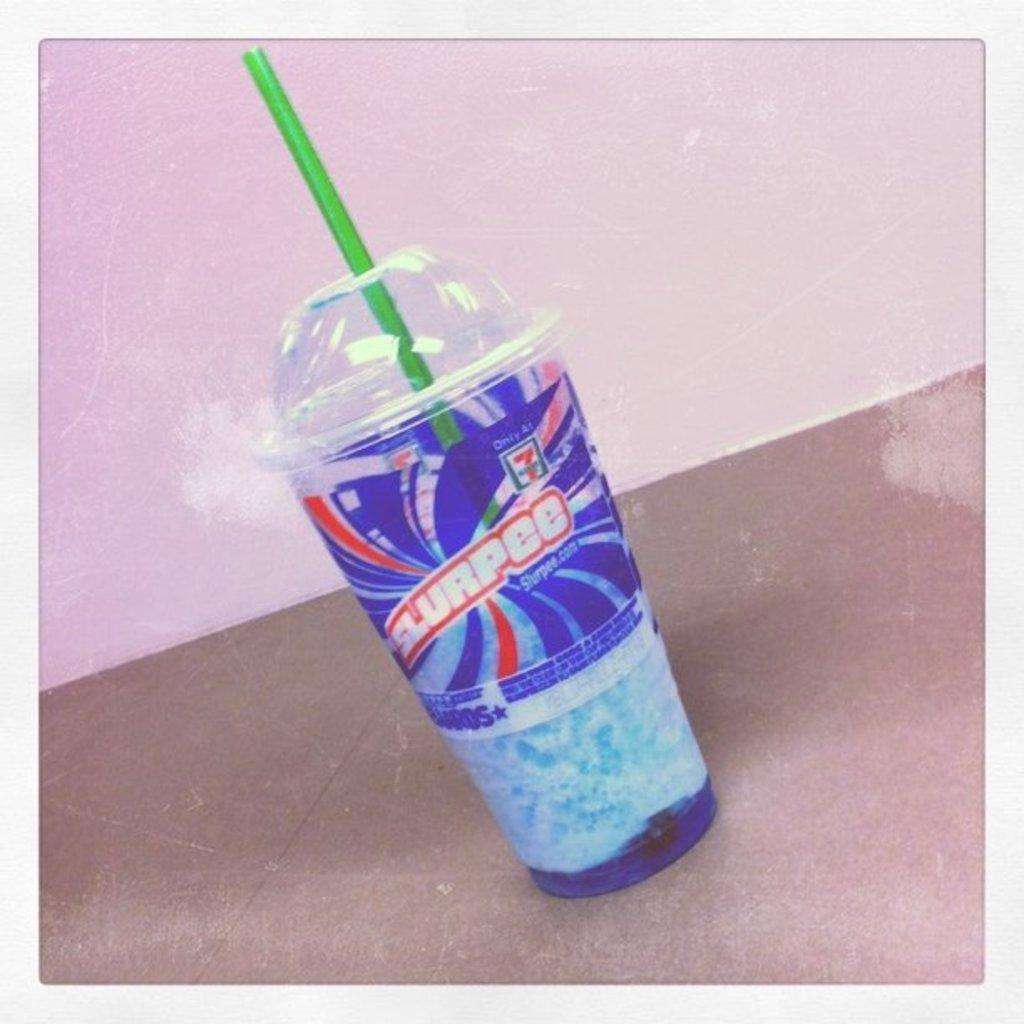What is present in the image? There is a cup in the image. What color is the cup? The cup is blue. What is the color of the surface the cup is on? The cup is on a brown surface. What is inside the cup? There is a green straw in the cup. What color is the background of the image? The background of the image is pale pink. What type of reward is being given to the pear in the image? There is no pear present in the image, and therefore no reward can be given to it. 